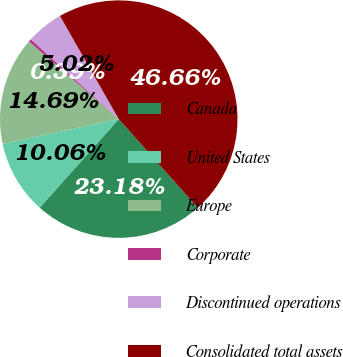Convert chart to OTSL. <chart><loc_0><loc_0><loc_500><loc_500><pie_chart><fcel>Canada<fcel>United States<fcel>Europe<fcel>Corporate<fcel>Discontinued operations<fcel>Consolidated total assets<nl><fcel>23.18%<fcel>10.06%<fcel>14.69%<fcel>0.39%<fcel>5.02%<fcel>46.66%<nl></chart> 